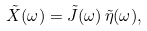Convert formula to latex. <formula><loc_0><loc_0><loc_500><loc_500>\tilde { X } ( \omega ) = \tilde { J } ( \omega ) \, \tilde { \eta } ( \omega ) ,</formula> 